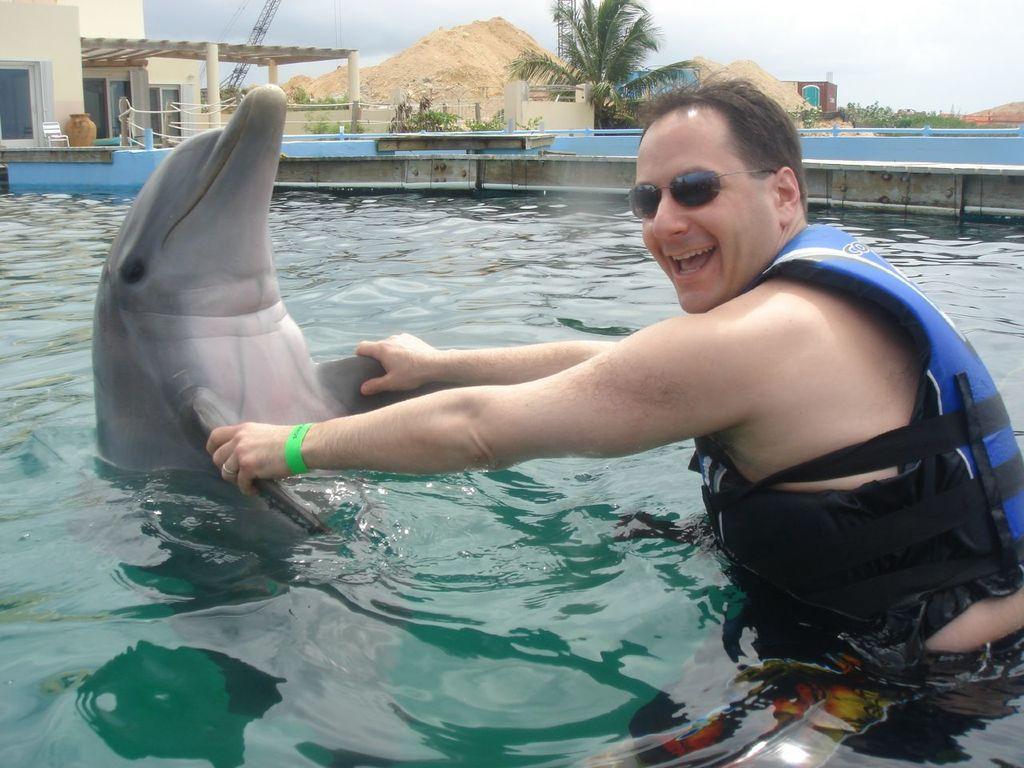Please provide a concise description of this image. In this image the person is playing with dolphin in swimming pool and behind the swimming pool there are buildings and trees are there and the background is very cloudy. 